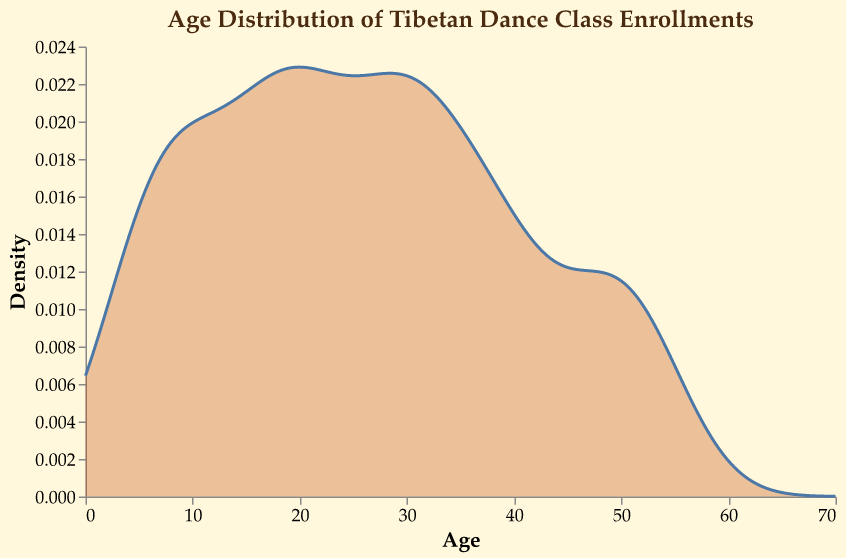What is the title of the figure? The title of the figure is displayed at the top of the chart and reads "Age Distribution of Tibetan Dance Class Enrollments".
Answer: "Age Distribution of Tibetan Dance Class Enrollments" What is the color of the density area in the plot? The density area in the plot is filled with a semi-transparent reddish-brown color. The line is also the same color.
Answer: Reddish-brown What is the age range shown on the x-axis? The x-axis represents the age range from the minimum value of 0 to the maximum value of 70.
Answer: 0 to 70 At which age is the highest density of enrollments observed? The highest density is the peak of the density plot. Count the enrollment peaks and locate the corresponding midpoint age.
Answer: 25 years How does the density of enrollments change from age 5 to age 10? Observe the height of the density plot between ages 5 and 10. The density slightly increases from age 5 to age 10.
Answer: Increases Which age group has the least density of enrollments based on the plot? The least dense area is represented by the lowest part of the density plot curve. Identify the age corresponding to the minimum density point.
Answer: 70 years old At what age does the density first start to decline? Look for the peak in the density plot and observe where it starts to decline after the initial rise. The decline starts after the highest density age.
Answer: 25 years How does the density at age 35 compare to the density at age 50? Compare the heights of the density plot at ages 35 and 50. The density at 35 is higher than the density at 50.
Answer: Higher at age 35 What is the overall trend of enrollments between ages 20 to 40? Analyze the density trend by tracing the plot line between ages 20 and 40. The trend sees an initial rise up to age 25 and then a gradual decline after.
Answer: Rises, then declines How would the density plot change if the number of enrollments at age 60 increased significantly? If the number of enrollments at age 60 increased, the density plot peak at this point would rise, increasing the area under the density line near age 60.
Answer: Increase in height at age 60 